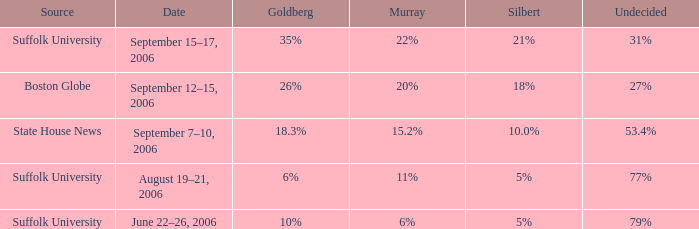On what date was the poll showing silbert at 10.0% held? September 7–10, 2006. 